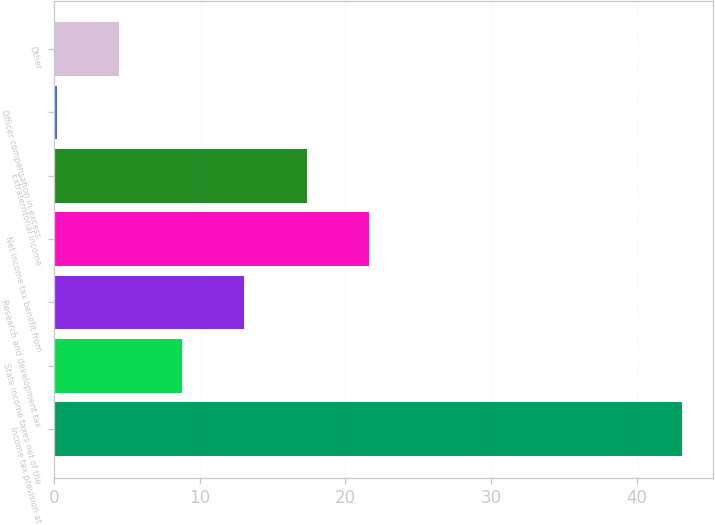Convert chart. <chart><loc_0><loc_0><loc_500><loc_500><bar_chart><fcel>Income tax provision at<fcel>State income taxes net of the<fcel>Research and development tax<fcel>Net income tax benefit from<fcel>Extraterritorial income<fcel>Officer compensation in excess<fcel>Other<nl><fcel>43.1<fcel>8.78<fcel>13.07<fcel>21.65<fcel>17.36<fcel>0.2<fcel>4.49<nl></chart> 